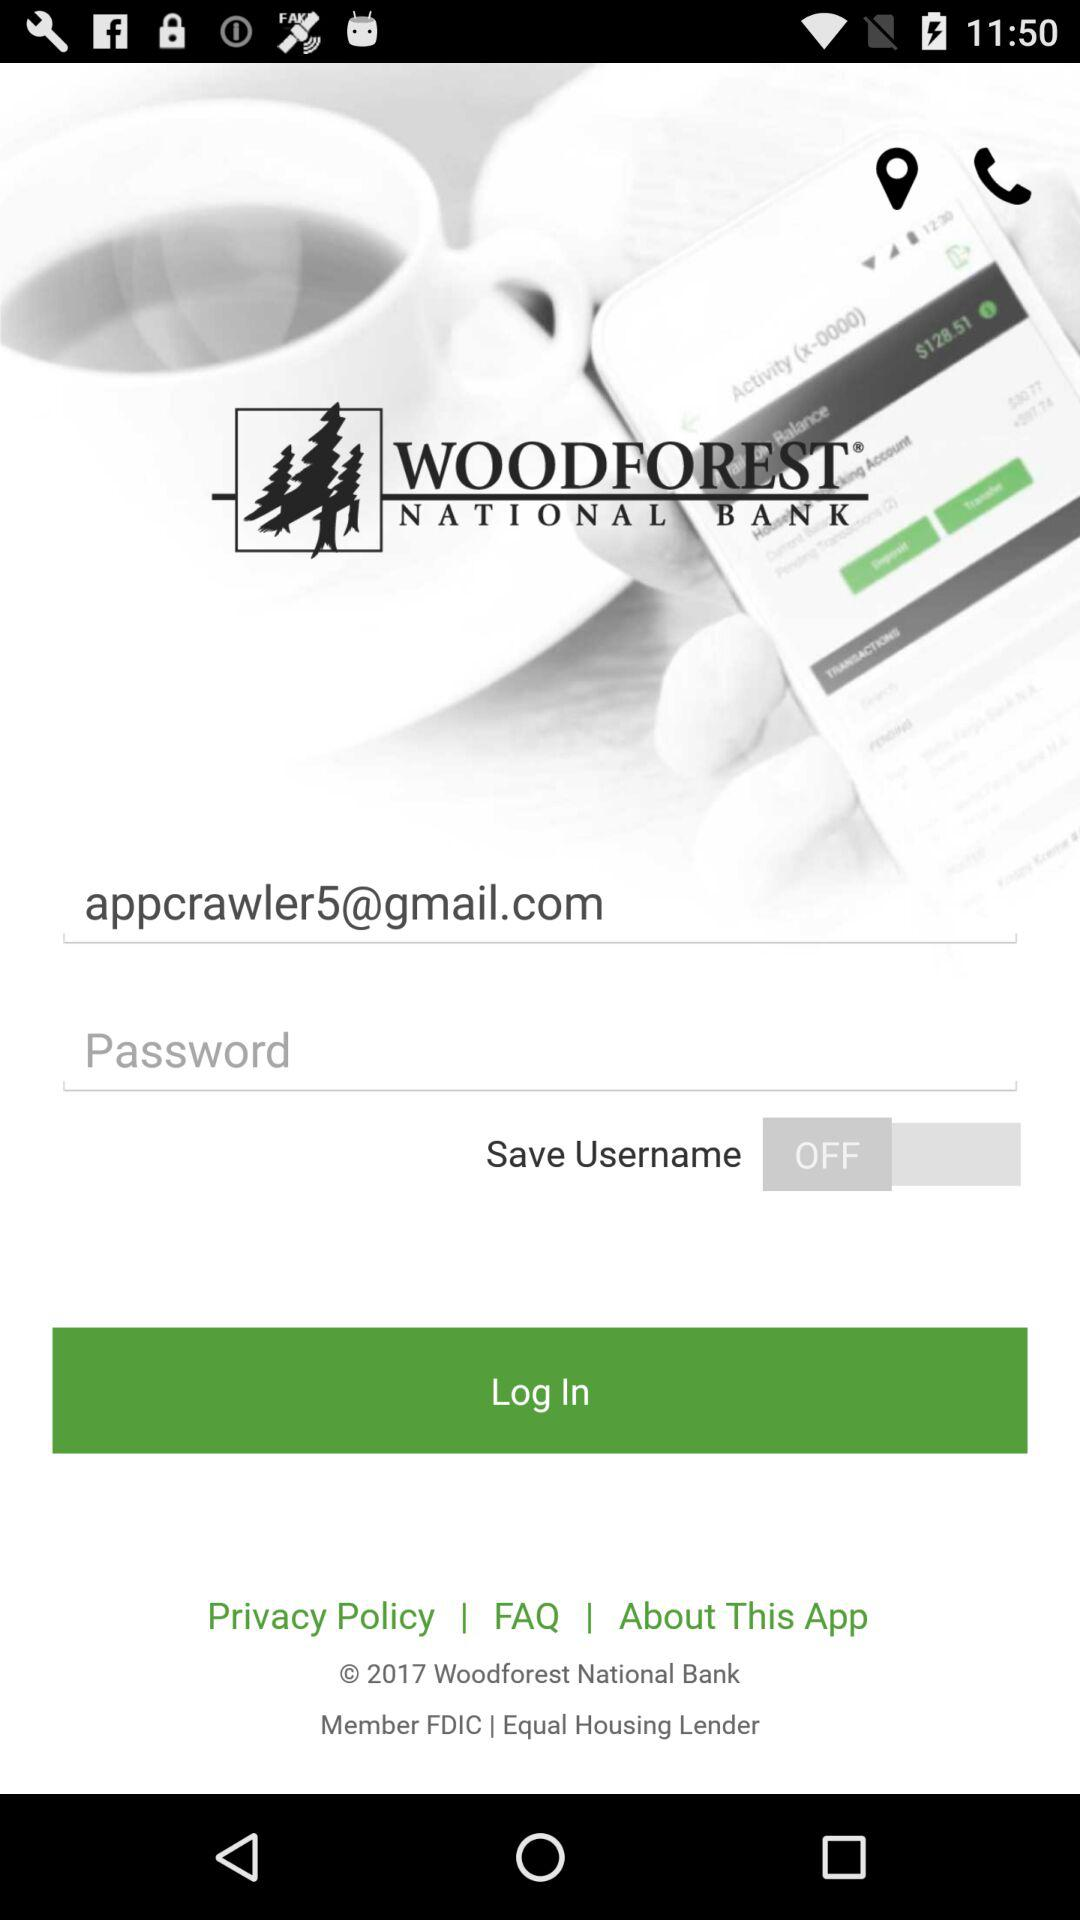What is the status of "Save Username"? The status is "off". 